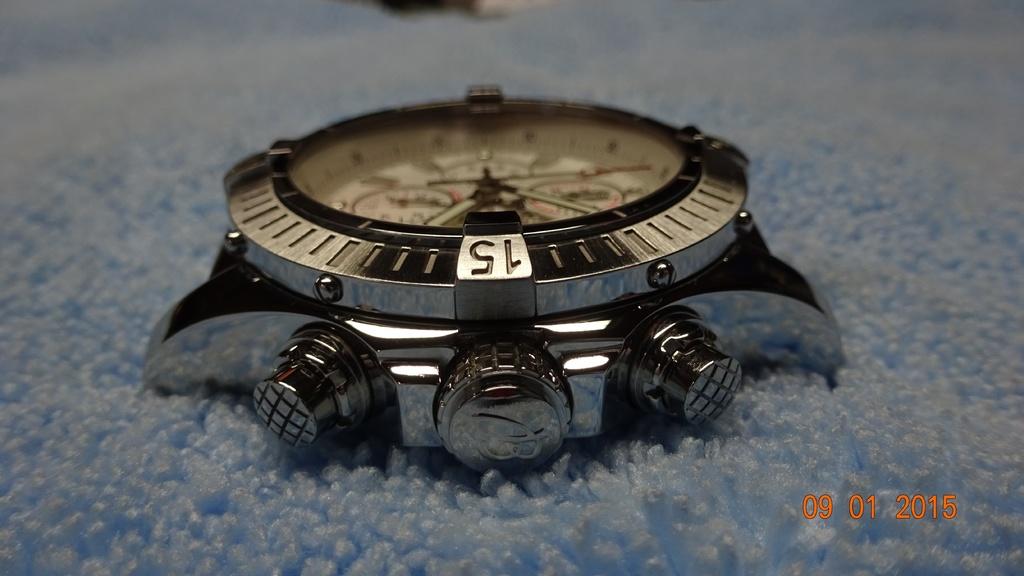When was this photo taken?
Make the answer very short. 09 01 2015. What's the large number?
Give a very brief answer. 15. 